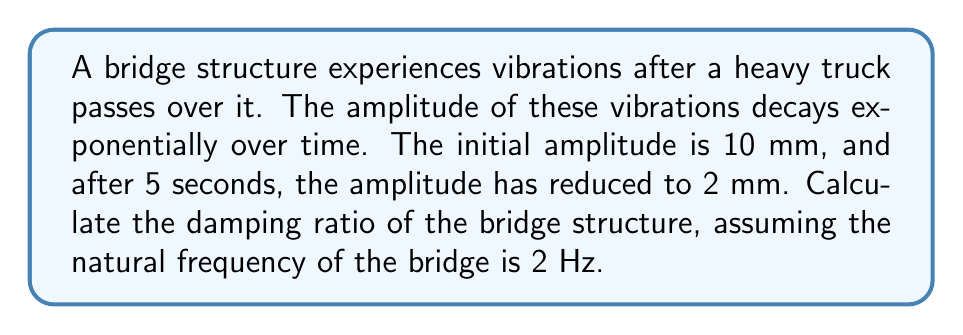Teach me how to tackle this problem. To solve this problem, we'll use the exponential decay function and the relationship between damping ratio and decay constant. Let's proceed step-by-step:

1) The exponential decay function is given by:
   $$A(t) = A_0 e^{-\zeta \omega_n t}$$
   where:
   $A(t)$ is the amplitude at time $t$
   $A_0$ is the initial amplitude
   $\zeta$ is the damping ratio
   $\omega_n$ is the natural angular frequency
   $t$ is the time

2) We're given:
   $A_0 = 10$ mm
   $A(5) = 2$ mm
   $f_n = 2$ Hz (natural frequency)

3) Convert frequency to angular frequency:
   $$\omega_n = 2\pi f_n = 2\pi(2) = 4\pi$$ rad/s

4) Substitute the values into the exponential decay function:
   $$2 = 10 e^{-\zeta (4\pi) (5)}$$

5) Take the natural log of both sides:
   $$\ln(0.2) = -20\pi\zeta$$

6) Solve for $\zeta$:
   $$\zeta = -\frac{\ln(0.2)}{20\pi} \approx 0.0512$$

7) Convert to percentage:
   $$\zeta \approx 5.12\%$$
Answer: 5.12% 